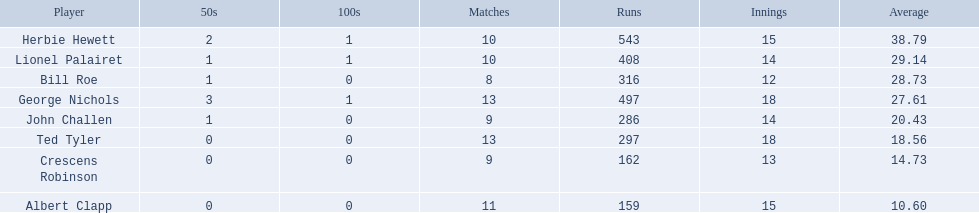Which players played in 10 or fewer matches? Herbie Hewett, Lionel Palairet, Bill Roe, John Challen, Crescens Robinson. Of these, which played in only 12 innings? Bill Roe. 